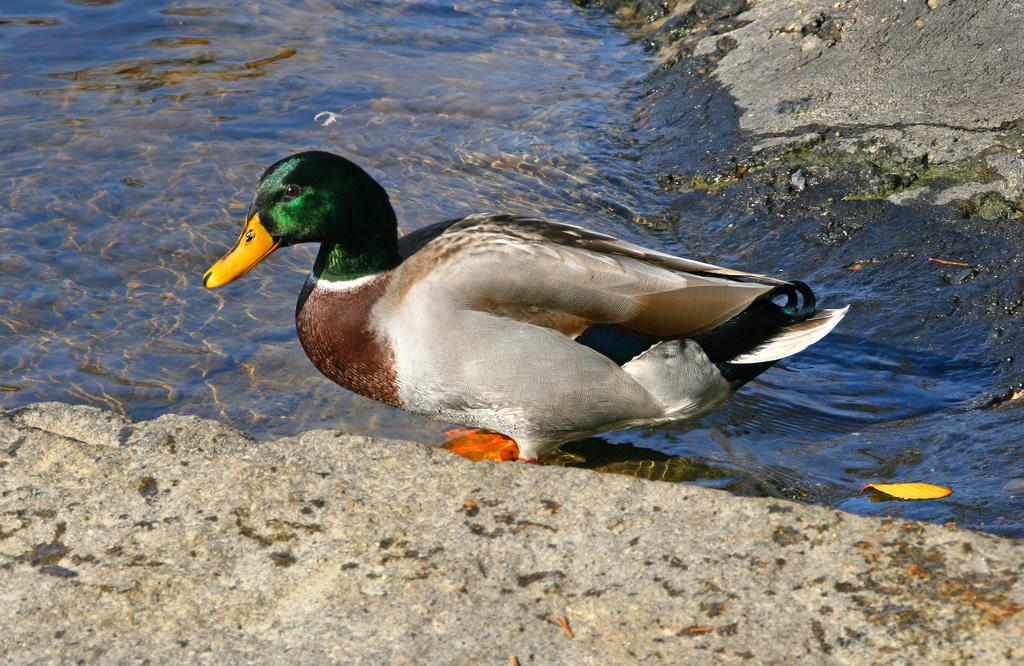What type of animal is in the image? There is a bird in the image. Can you describe the colors of the bird? The bird has yellow, green, brown, black, and white colors. Where is the bird located in the image? The bird is in the water. What else can be seen in the image besides the bird? There are rocks visible in the image. How many children are playing peacefully on the base in the image? There are no children or base present in the image; it features a bird in the water and rocks. 